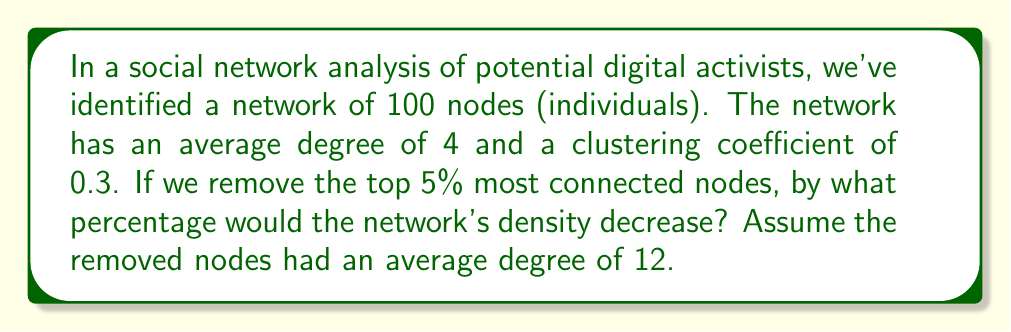What is the answer to this math problem? Let's approach this step-by-step:

1) First, let's calculate the initial network density:
   - Network density = $\frac{\text{Total edges}}{\text{Possible edges}}$
   - Total edges = $\frac{\text{Nodes} \times \text{Average degree}}{2} = \frac{100 \times 4}{2} = 200$
   - Possible edges = $\frac{n(n-1)}{2} = \frac{100 \times 99}{2} = 4950$
   - Initial density = $\frac{200}{4950} \approx 0.0404$

2) Now, let's calculate the edges removed when we take out the top 5% (5 nodes):
   - Edges removed = $5 \times 12 = 60$ (as these nodes had an average degree of 12)

3) Calculate the new number of edges:
   - New total edges = $200 - 60 = 140$

4) Calculate the new possible edges with 95 nodes:
   - New possible edges = $\frac{95 \times 94}{2} = 4465$

5) Calculate the new density:
   - New density = $\frac{140}{4465} \approx 0.0313$

6) Calculate the percentage decrease:
   - Percentage decrease = $\frac{\text{Old density} - \text{New density}}{\text{Old density}} \times 100\%$
   - $= \frac{0.0404 - 0.0313}{0.0404} \times 100\% \approx 22.52\%$
Answer: 22.52% 